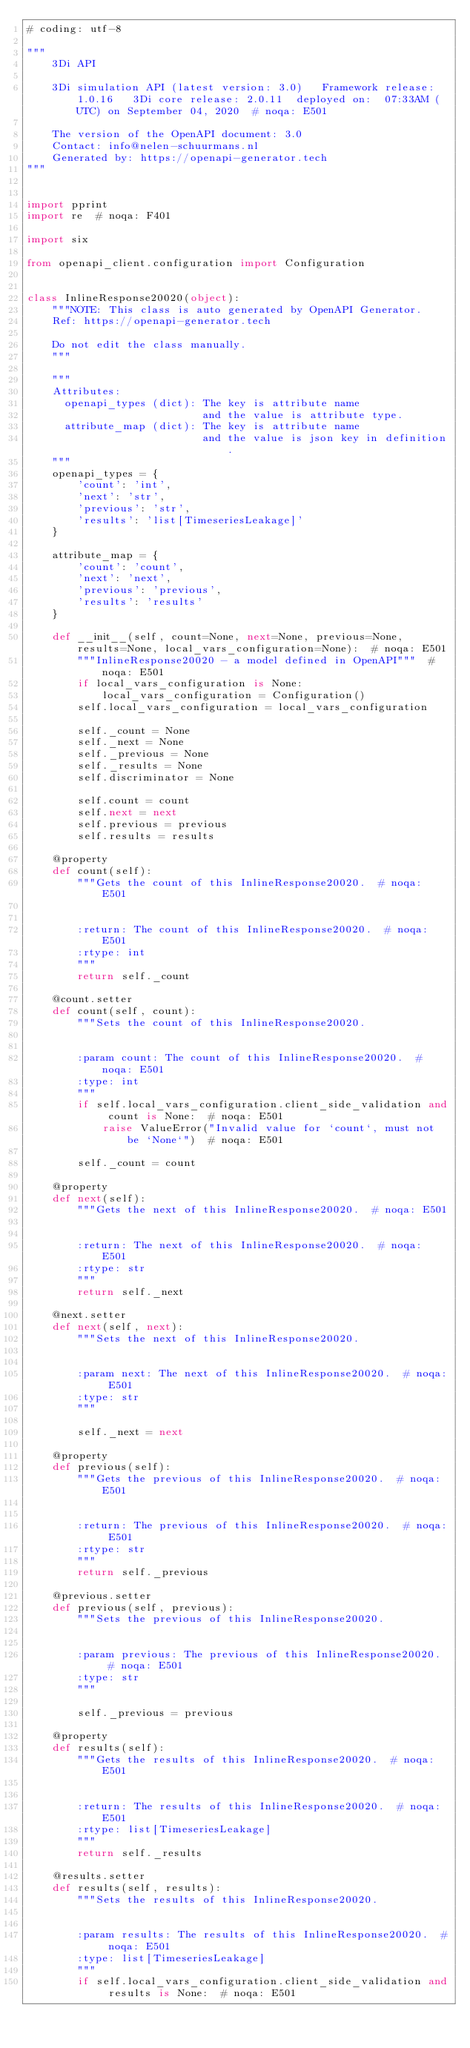Convert code to text. <code><loc_0><loc_0><loc_500><loc_500><_Python_># coding: utf-8

"""
    3Di API

    3Di simulation API (latest version: 3.0)   Framework release: 1.0.16   3Di core release: 2.0.11  deployed on:  07:33AM (UTC) on September 04, 2020  # noqa: E501

    The version of the OpenAPI document: 3.0
    Contact: info@nelen-schuurmans.nl
    Generated by: https://openapi-generator.tech
"""


import pprint
import re  # noqa: F401

import six

from openapi_client.configuration import Configuration


class InlineResponse20020(object):
    """NOTE: This class is auto generated by OpenAPI Generator.
    Ref: https://openapi-generator.tech

    Do not edit the class manually.
    """

    """
    Attributes:
      openapi_types (dict): The key is attribute name
                            and the value is attribute type.
      attribute_map (dict): The key is attribute name
                            and the value is json key in definition.
    """
    openapi_types = {
        'count': 'int',
        'next': 'str',
        'previous': 'str',
        'results': 'list[TimeseriesLeakage]'
    }

    attribute_map = {
        'count': 'count',
        'next': 'next',
        'previous': 'previous',
        'results': 'results'
    }

    def __init__(self, count=None, next=None, previous=None, results=None, local_vars_configuration=None):  # noqa: E501
        """InlineResponse20020 - a model defined in OpenAPI"""  # noqa: E501
        if local_vars_configuration is None:
            local_vars_configuration = Configuration()
        self.local_vars_configuration = local_vars_configuration

        self._count = None
        self._next = None
        self._previous = None
        self._results = None
        self.discriminator = None

        self.count = count
        self.next = next
        self.previous = previous
        self.results = results

    @property
    def count(self):
        """Gets the count of this InlineResponse20020.  # noqa: E501


        :return: The count of this InlineResponse20020.  # noqa: E501
        :rtype: int
        """
        return self._count

    @count.setter
    def count(self, count):
        """Sets the count of this InlineResponse20020.


        :param count: The count of this InlineResponse20020.  # noqa: E501
        :type: int
        """
        if self.local_vars_configuration.client_side_validation and count is None:  # noqa: E501
            raise ValueError("Invalid value for `count`, must not be `None`")  # noqa: E501

        self._count = count

    @property
    def next(self):
        """Gets the next of this InlineResponse20020.  # noqa: E501


        :return: The next of this InlineResponse20020.  # noqa: E501
        :rtype: str
        """
        return self._next

    @next.setter
    def next(self, next):
        """Sets the next of this InlineResponse20020.


        :param next: The next of this InlineResponse20020.  # noqa: E501
        :type: str
        """

        self._next = next

    @property
    def previous(self):
        """Gets the previous of this InlineResponse20020.  # noqa: E501


        :return: The previous of this InlineResponse20020.  # noqa: E501
        :rtype: str
        """
        return self._previous

    @previous.setter
    def previous(self, previous):
        """Sets the previous of this InlineResponse20020.


        :param previous: The previous of this InlineResponse20020.  # noqa: E501
        :type: str
        """

        self._previous = previous

    @property
    def results(self):
        """Gets the results of this InlineResponse20020.  # noqa: E501


        :return: The results of this InlineResponse20020.  # noqa: E501
        :rtype: list[TimeseriesLeakage]
        """
        return self._results

    @results.setter
    def results(self, results):
        """Sets the results of this InlineResponse20020.


        :param results: The results of this InlineResponse20020.  # noqa: E501
        :type: list[TimeseriesLeakage]
        """
        if self.local_vars_configuration.client_side_validation and results is None:  # noqa: E501</code> 